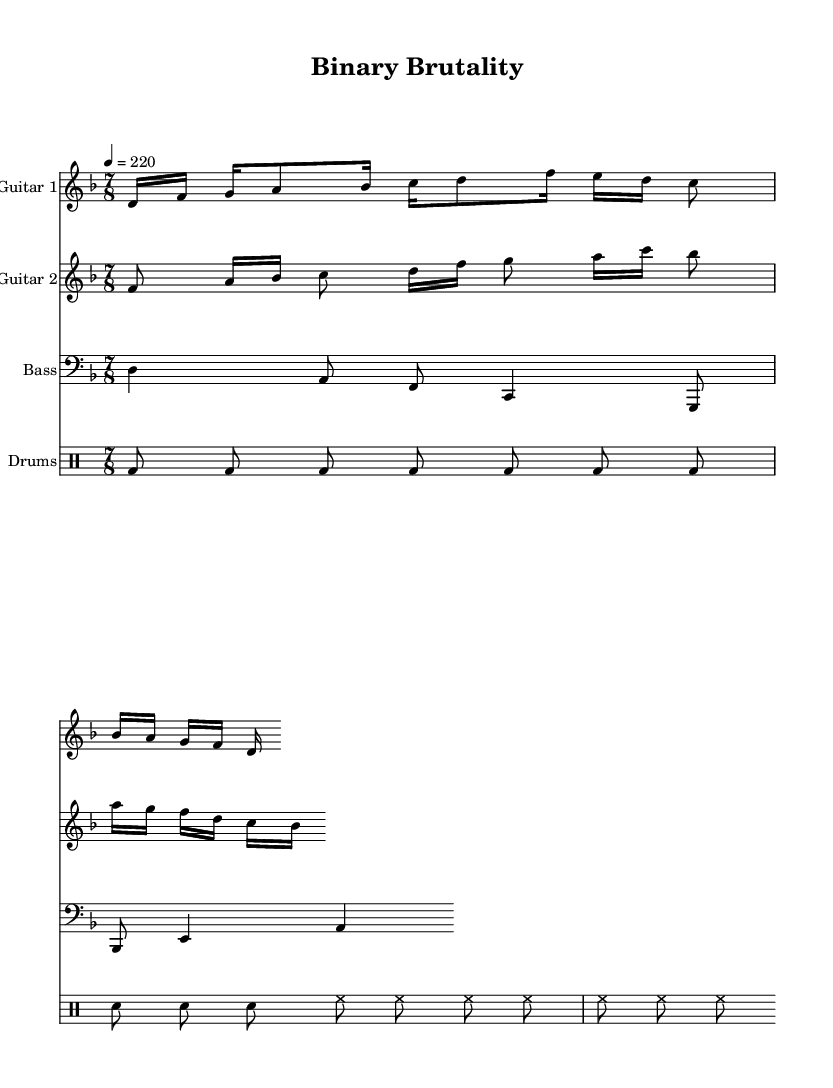What is the key signature of this music? The key signature indicates the presence of one flat, which corresponds to D minor. This is derived from the global settings in the code labeled under `global`.
Answer: D minor What is the time signature of this piece? The time signature is noted in the global settings as 7/8, which can be found directly in the `global` variable declaration section of the code.
Answer: 7/8 What is the tempo marking? The tempo marking specifies that the piece should be played at a quarter note speed of 220 beats per minute. This is explicitly stated in the `global` section of the code.
Answer: 220 What is the main rhythmic feel of the drums in this piece? The drums maintain a consistent eighth note pulse characterized by repeated kick and snare hits, emphasizing a typical metal styling. The analysis of the `drumsPitches` section shows the pattern of repeated bass drum hits and snare placements.
Answer: Repetitive What does the notation in the second guitar part suggest about its role? The second guitar part complements the first with a contrasting rhythm and melodic line, showcasing typical technical death metal layering wherein multiple guitar tracks interlock for a complex sound experience. Observing the interplay between note values indicates a distinct arrangement designed for complexity.
Answer: Complementary How does the choice of 7/8 time signature impact the composition? Utilizing a 7/8 time signature introduces an asymmetrical rhythmic structure, characteristic of progressive metal genres. This choice creates a unique feel that deviates from conventional meter patterns, allowing for more intricate compositions and coding-like complexity. The 7/8 indicates that notes do not easily fall into a simple count, emphasizing the technical nature of the music.
Answer: Asymmetrical 